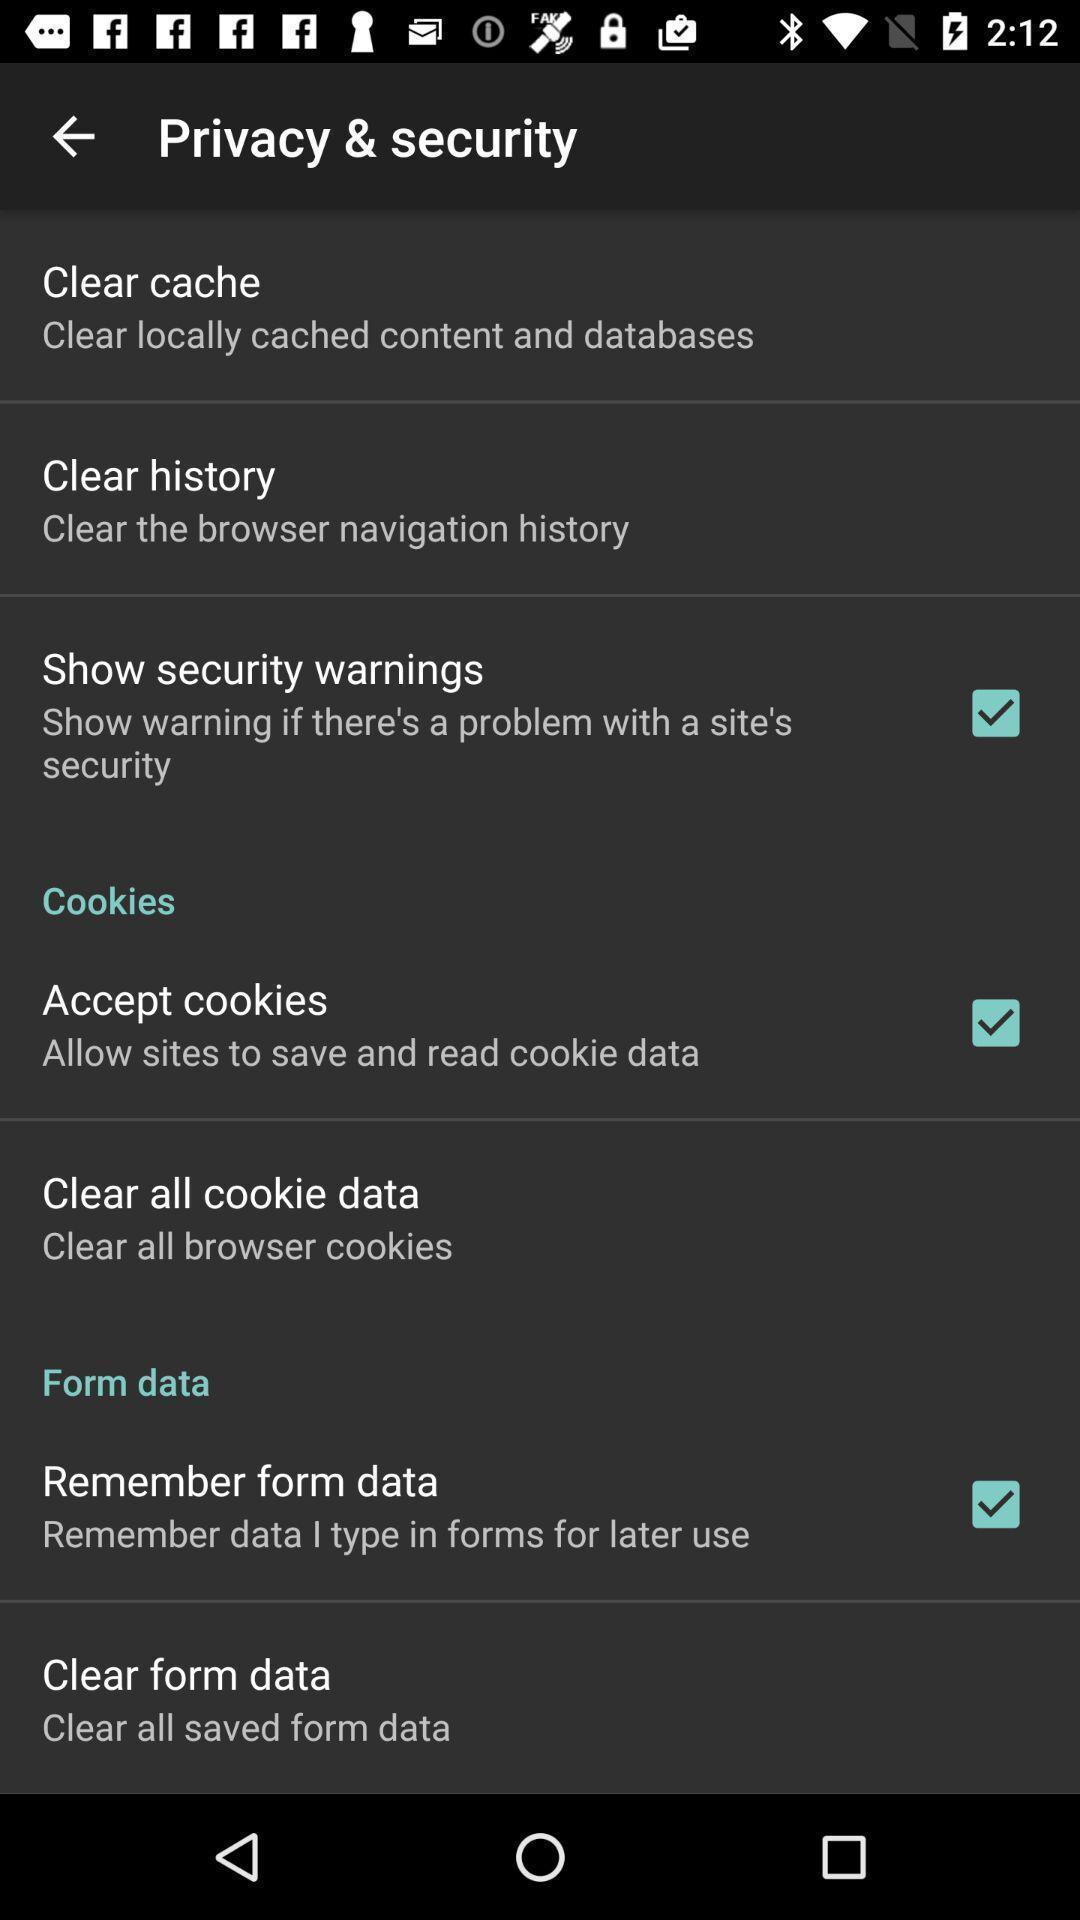Give me a narrative description of this picture. Screen shows privacy security details. 